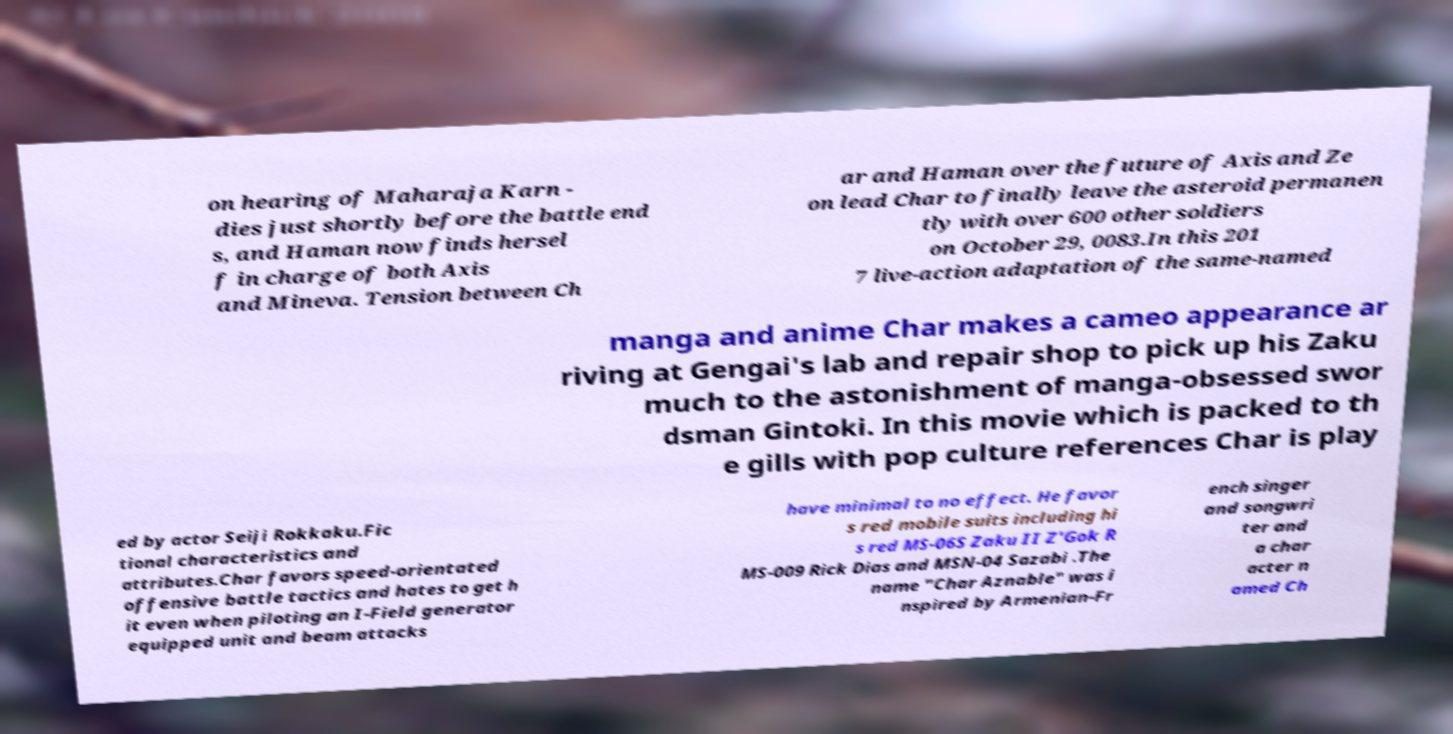Please identify and transcribe the text found in this image. on hearing of Maharaja Karn - dies just shortly before the battle end s, and Haman now finds hersel f in charge of both Axis and Mineva. Tension between Ch ar and Haman over the future of Axis and Ze on lead Char to finally leave the asteroid permanen tly with over 600 other soldiers on October 29, 0083.In this 201 7 live-action adaptation of the same-named manga and anime Char makes a cameo appearance ar riving at Gengai's lab and repair shop to pick up his Zaku much to the astonishment of manga-obsessed swor dsman Gintoki. In this movie which is packed to th e gills with pop culture references Char is play ed by actor Seiji Rokkaku.Fic tional characteristics and attributes.Char favors speed-orientated offensive battle tactics and hates to get h it even when piloting an I-Field generator equipped unit and beam attacks have minimal to no effect. He favor s red mobile suits including hi s red MS-06S Zaku II Z'Gok R MS-009 Rick Dias and MSN-04 Sazabi .The name "Char Aznable" was i nspired by Armenian-Fr ench singer and songwri ter and a char acter n amed Ch 